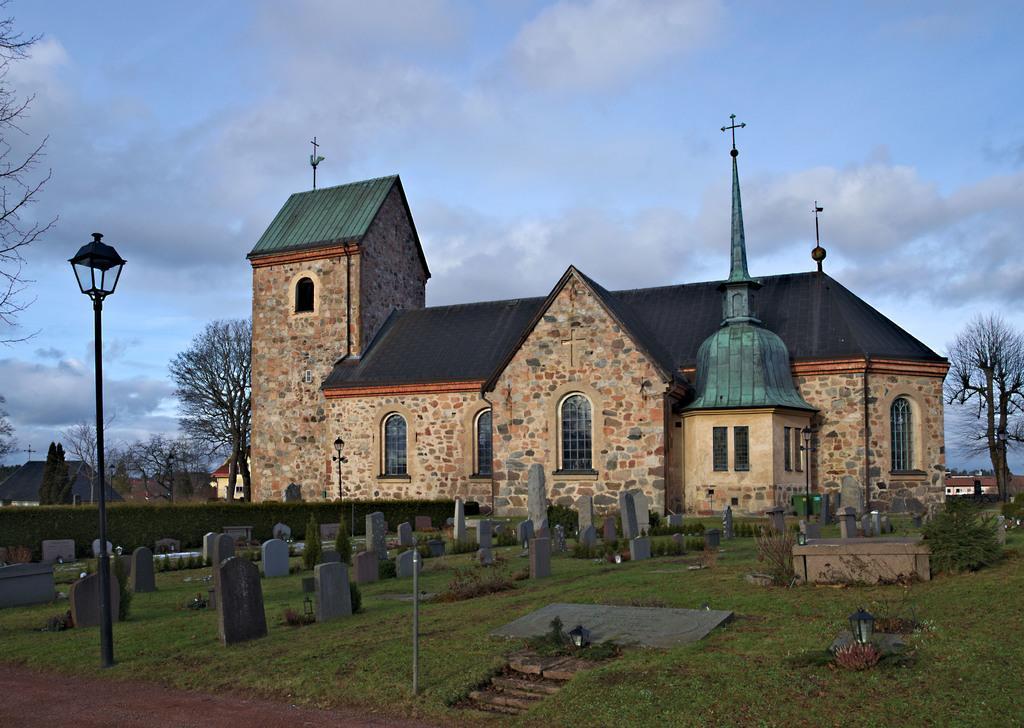Could you give a brief overview of what you see in this image? In this image we can see the church, light poles, trees, houses and also the graveyard stones. We can also see the grass, path and also the sky with the clouds in the background. We can also see the creepers wall. 